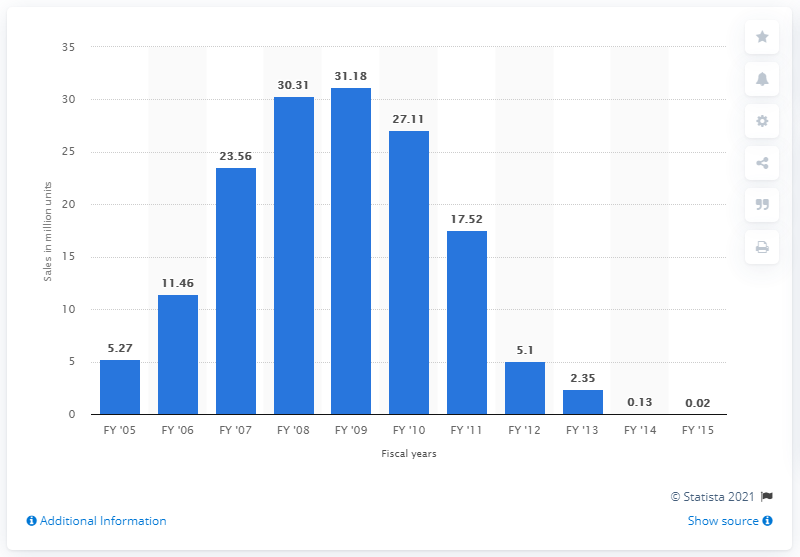Indicate a few pertinent items in this graphic. In the 2009/10 financial year, Nintendo sold 27.11 million units of the Nintendo DS. 